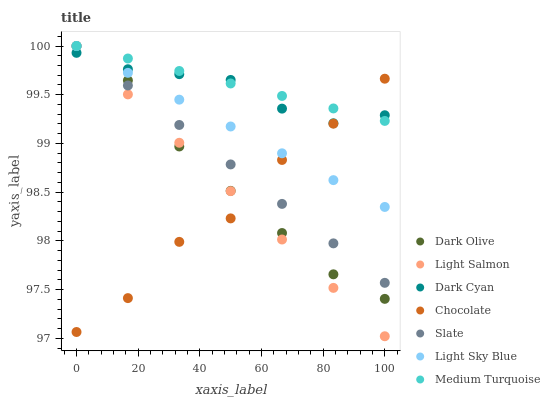Does Chocolate have the minimum area under the curve?
Answer yes or no. Yes. Does Medium Turquoise have the maximum area under the curve?
Answer yes or no. Yes. Does Slate have the minimum area under the curve?
Answer yes or no. No. Does Slate have the maximum area under the curve?
Answer yes or no. No. Is Light Sky Blue the smoothest?
Answer yes or no. Yes. Is Chocolate the roughest?
Answer yes or no. Yes. Is Slate the smoothest?
Answer yes or no. No. Is Slate the roughest?
Answer yes or no. No. Does Light Salmon have the lowest value?
Answer yes or no. Yes. Does Slate have the lowest value?
Answer yes or no. No. Does Medium Turquoise have the highest value?
Answer yes or no. Yes. Does Chocolate have the highest value?
Answer yes or no. No. Does Medium Turquoise intersect Slate?
Answer yes or no. Yes. Is Medium Turquoise less than Slate?
Answer yes or no. No. Is Medium Turquoise greater than Slate?
Answer yes or no. No. 